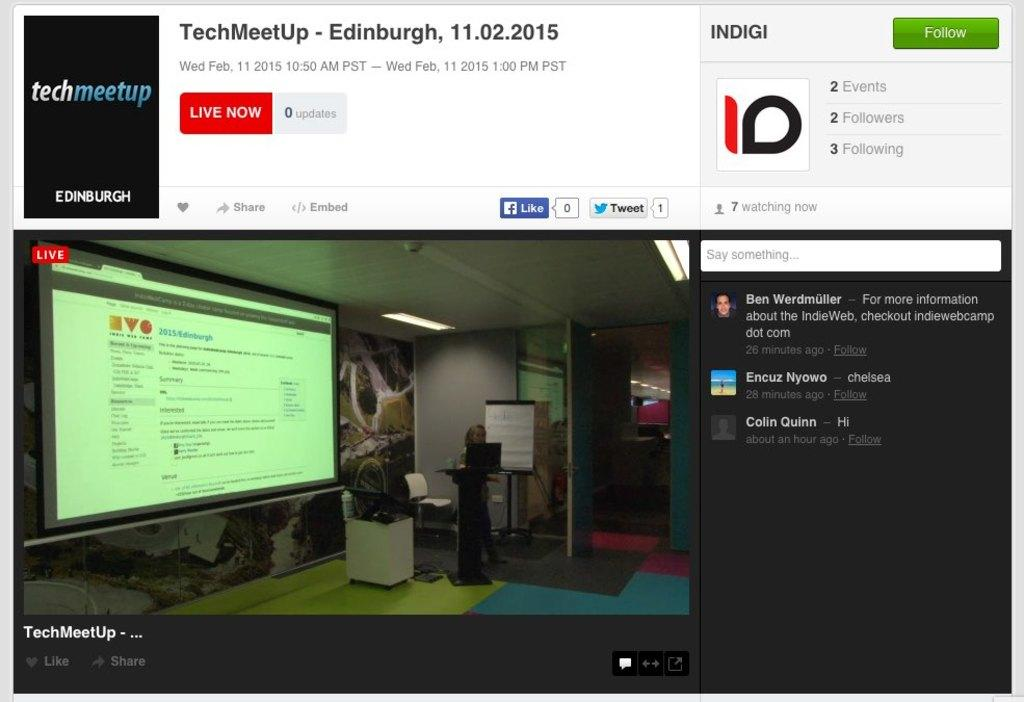<image>
Relay a brief, clear account of the picture shown. Screen showing the name Colin Quinn on the left. 